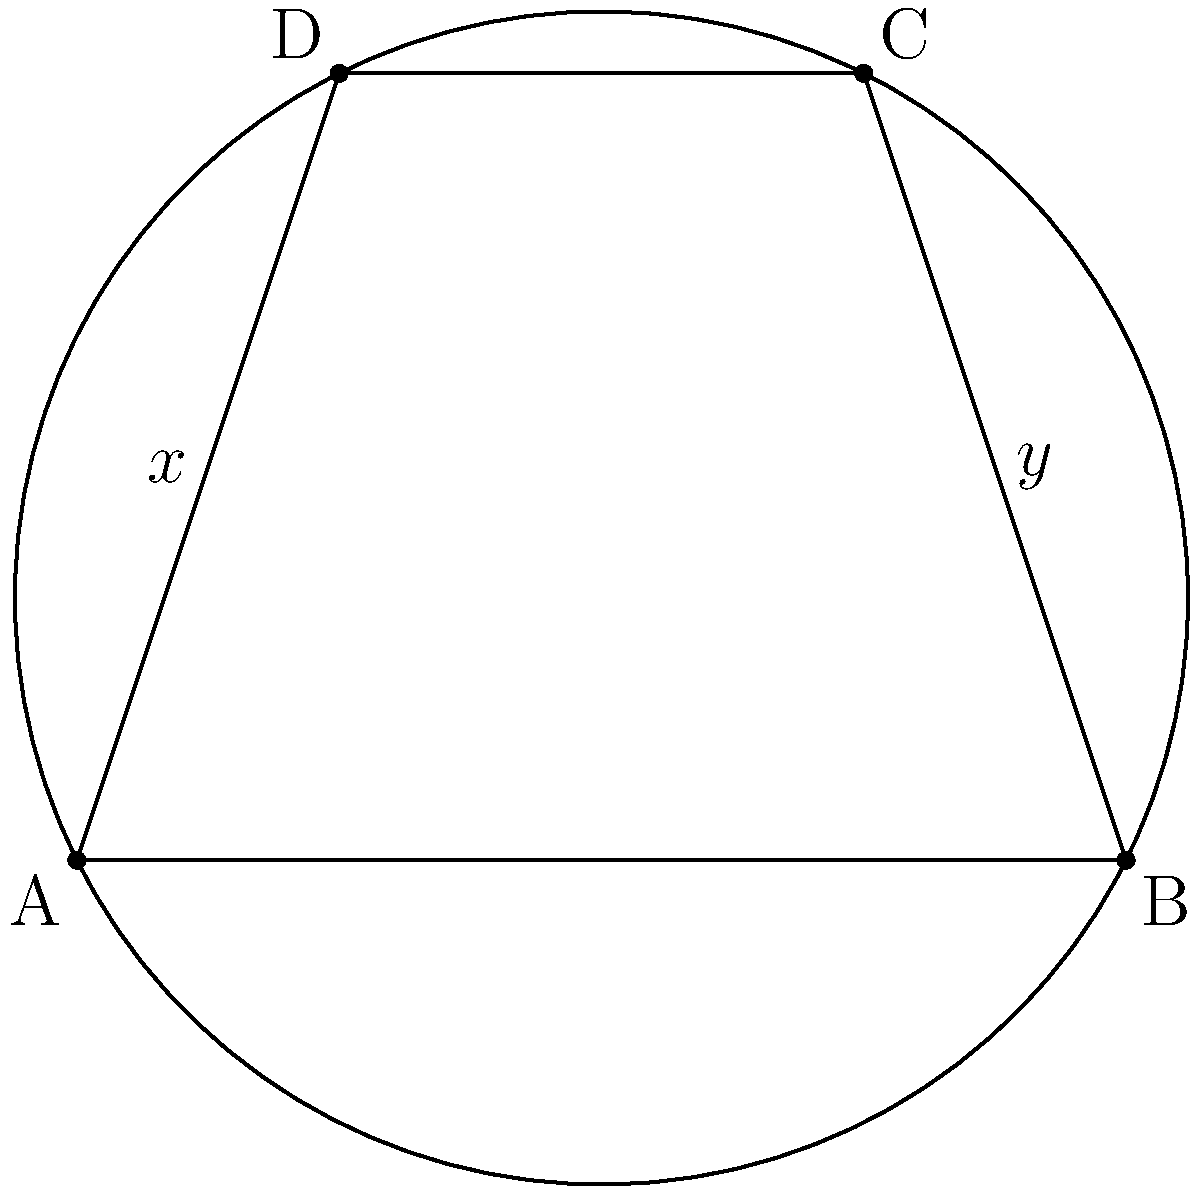In the cyclic quadrilateral $ABCD$, angles $DAB$ and $BCD$ are denoted as $x°$ and $y°$ respectively. What is the relationship between $x$ and $y$, and how does this relate to the properties of cyclic quadrilaterals? To understand the relationship between $x$ and $y$, let's follow these steps:

1) In a cyclic quadrilateral, opposite angles are supplementary. This means their sum is always 180°.

2) Therefore, we can write:
   $$x° + y° = 180°$$

3) This property stems from the fact that angles in the same segment of a circle are equal:
   - Angle $DAB$ and angle $DCB$ are in the same segment (arc $DB$)
   - Angle $BCD$ and angle $BAD$ are in the same segment (arc $BC$)

4) The sum of these four angles (two pairs of equal angles) must be 360° (as in any quadrilateral).

5) Since opposite angles are equal, each pair must sum to half of 360°, which is 180°.

This relationship holds true for all cyclic quadrilaterals, regardless of their specific shape or size. It's a fundamental property that distinguishes cyclic quadrilaterals from other types of quadrilaterals.
Answer: $x° + y° = 180°$ 